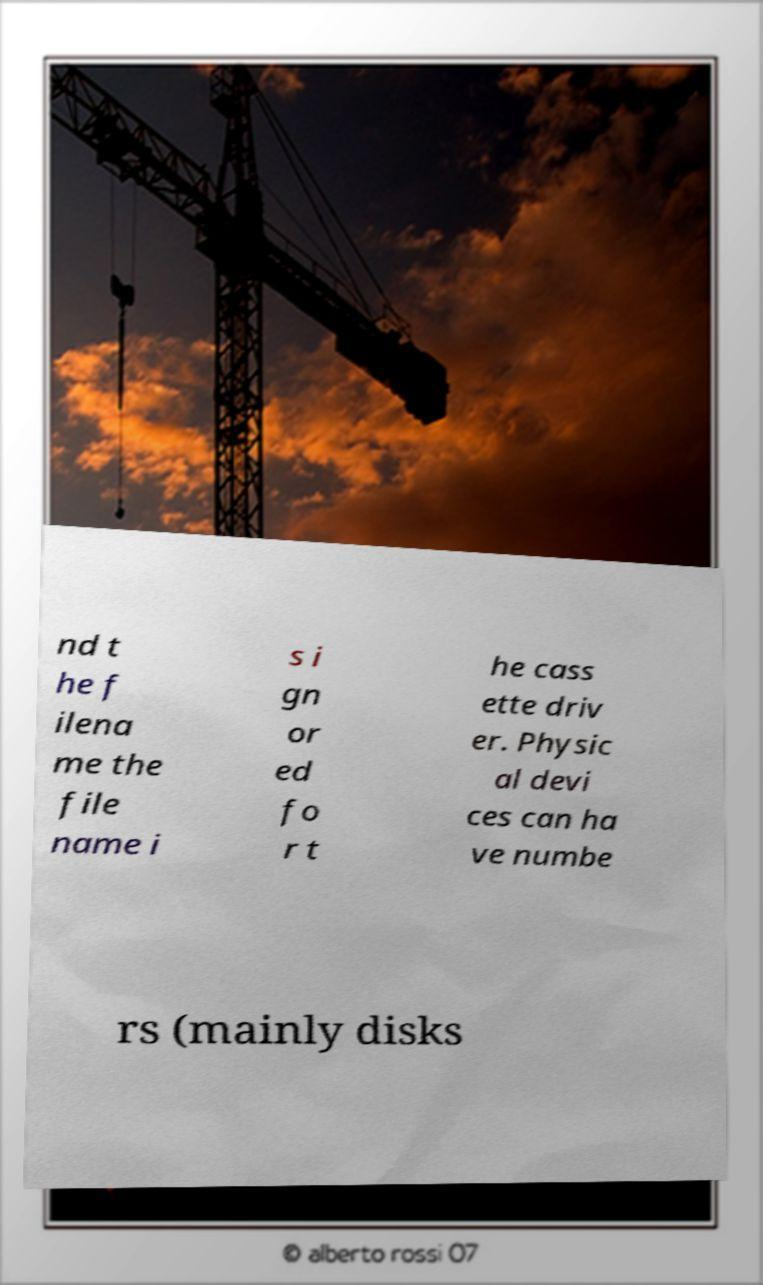What messages or text are displayed in this image? I need them in a readable, typed format. nd t he f ilena me the file name i s i gn or ed fo r t he cass ette driv er. Physic al devi ces can ha ve numbe rs (mainly disks 